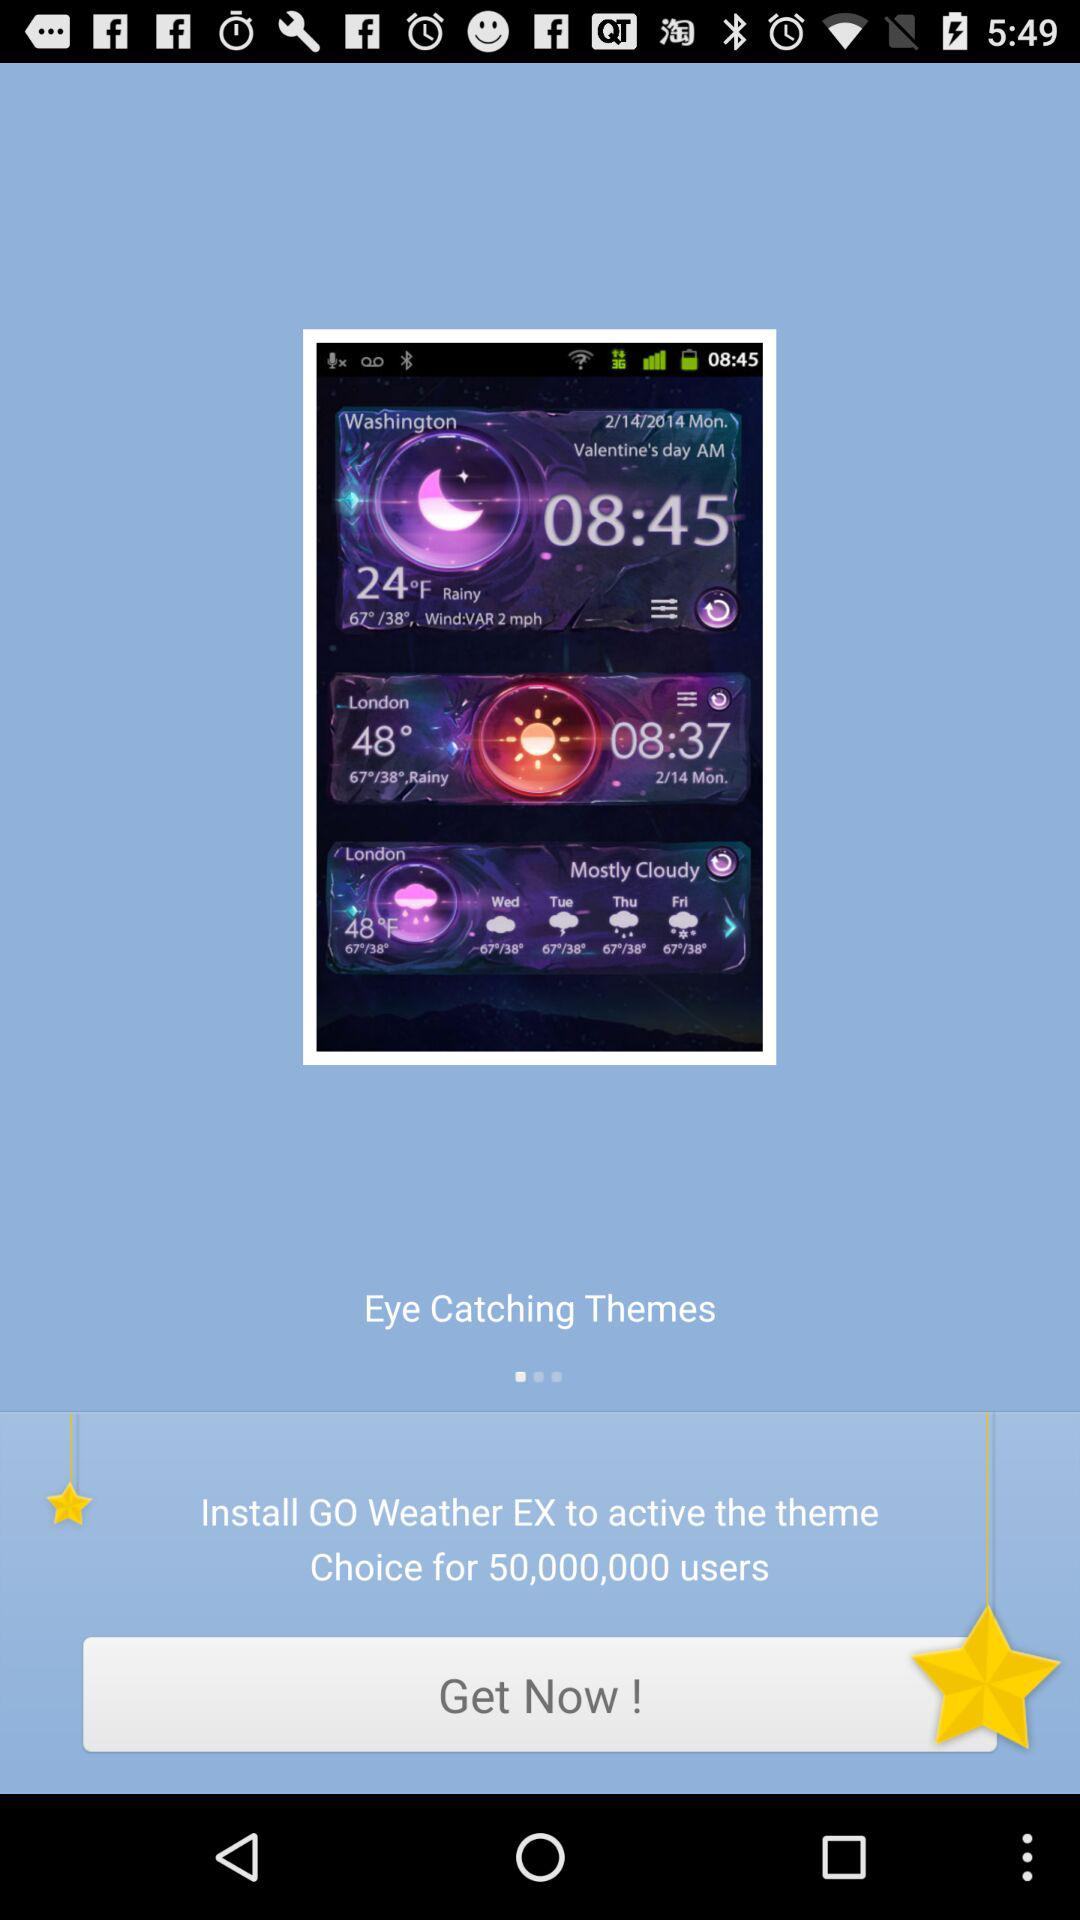What is the temperature in Washington in Fahrenheit? The temperature is 24 °F. 